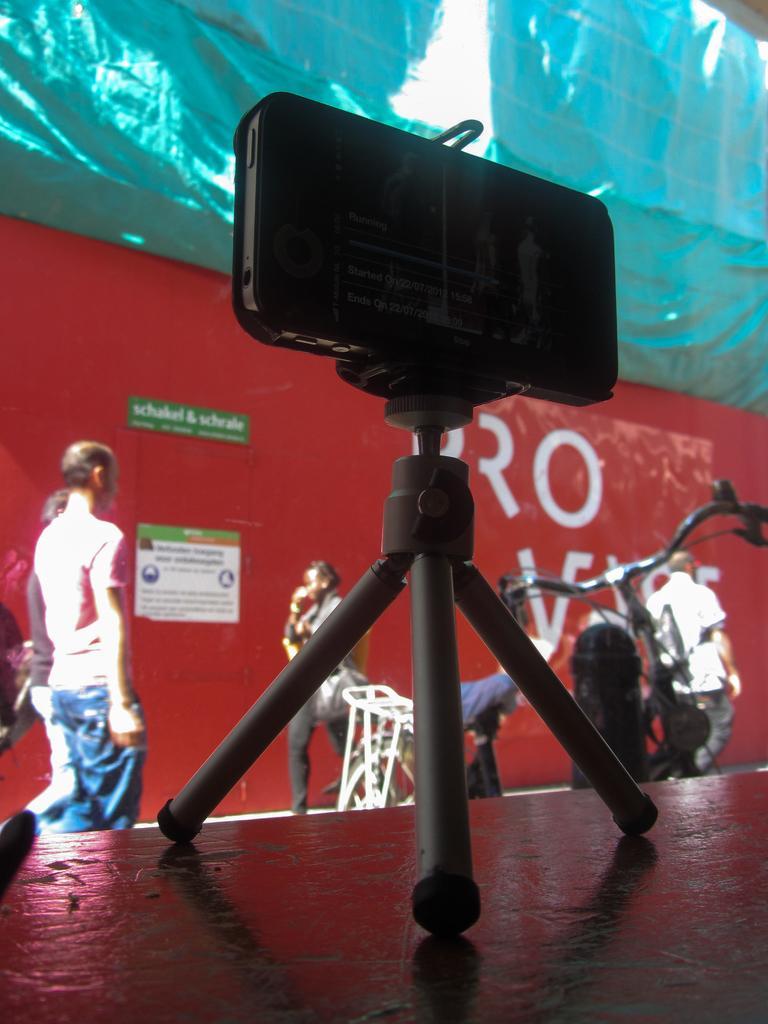Describe this image in one or two sentences. In the picture we can see some object which is holding mobile phone is placed on the surface, we can see a bicycle which is parked and in the background of the picture there are some persons walking and there is a wall which is red in color. 